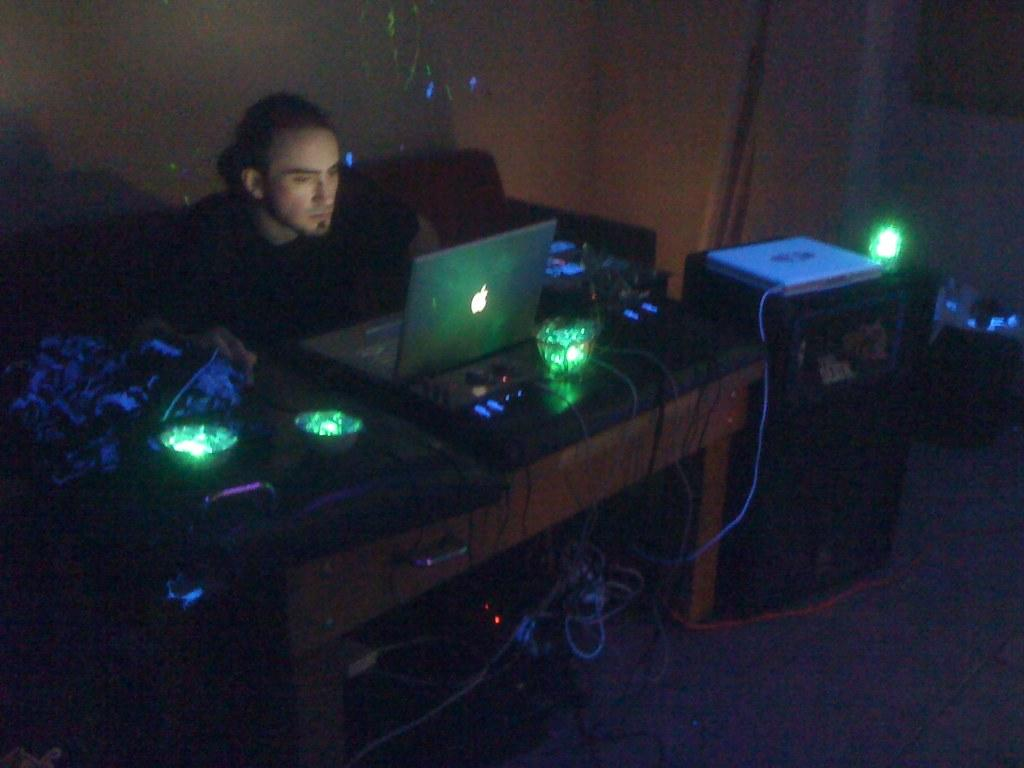What is the man in the image doing? The man is sitting on a sofa. What objects are on the table in the image? There are laptops and lights on the table. What can be seen on the floor in the image? There are wires on the floor. What is visible in the background of the image? The background of the image includes a wall. What type of polish is being applied to the circle in the image? There is no polish or circle present in the image. 